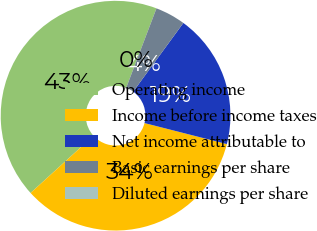Convert chart. <chart><loc_0><loc_0><loc_500><loc_500><pie_chart><fcel>Operating income<fcel>Income before income taxes<fcel>Net income attributable to<fcel>Basic earnings per share<fcel>Diluted earnings per share<nl><fcel>42.54%<fcel>34.28%<fcel>18.93%<fcel>4.25%<fcel>0.0%<nl></chart> 